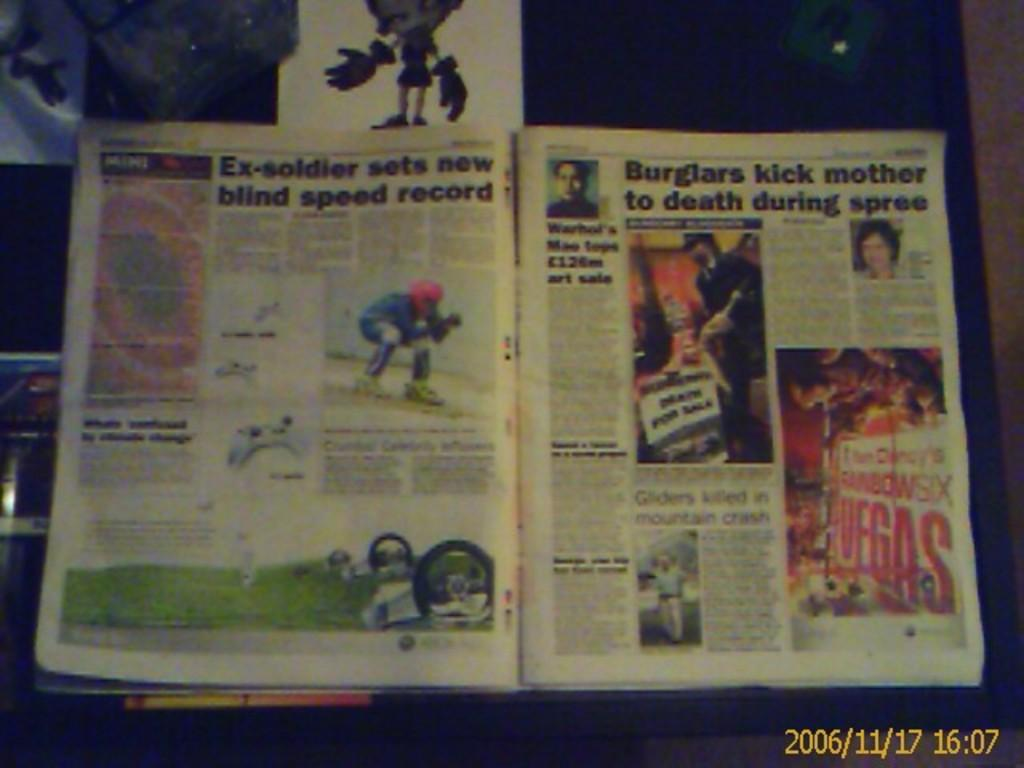<image>
Render a clear and concise summary of the photo. Ex-soldier sets a new blind speed record is the headline of an article. 